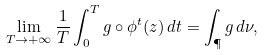Convert formula to latex. <formula><loc_0><loc_0><loc_500><loc_500>\lim _ { T \to + \infty } \frac { 1 } { T } \int _ { 0 } ^ { T } g \circ \phi ^ { t } ( z ) \, d t = \int _ { \P } g \, d \nu ,</formula> 